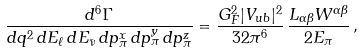<formula> <loc_0><loc_0><loc_500><loc_500>\frac { d ^ { 6 } \Gamma } { d q ^ { 2 } \, d E _ { \ell } \, d E _ { \bar { \nu } } \, d p _ { \pi } ^ { x } \, d p _ { \pi } ^ { y } \, d p _ { \pi } ^ { z } } & = \frac { G _ { F } ^ { 2 } | V _ { u b } | ^ { 2 } } { 3 2 \pi ^ { 6 } } \, \frac { L _ { \alpha \beta } W ^ { \alpha \beta } } { 2 E _ { \pi } } \, ,</formula> 